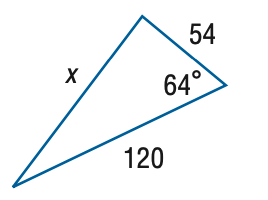Question: Find x. Round the side measure to the nearest tenth.
Choices:
A. 53.9
B. 107.9
C. 215.7
D. 323.6
Answer with the letter. Answer: B 